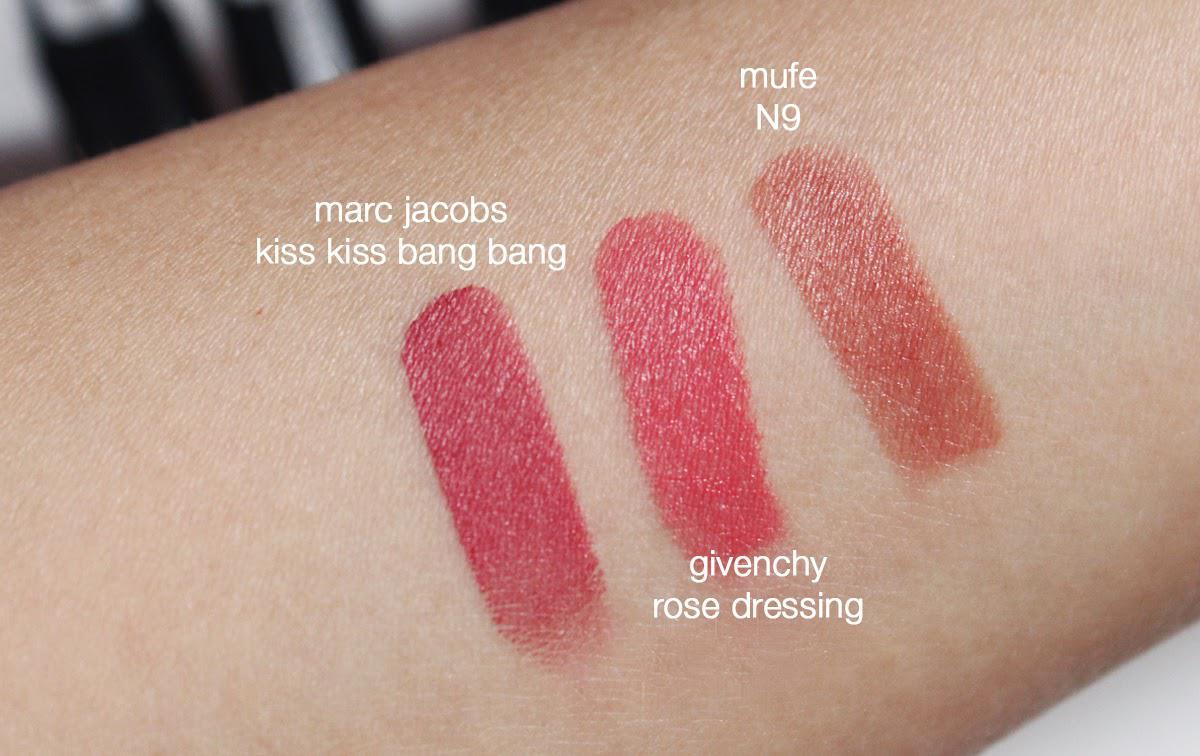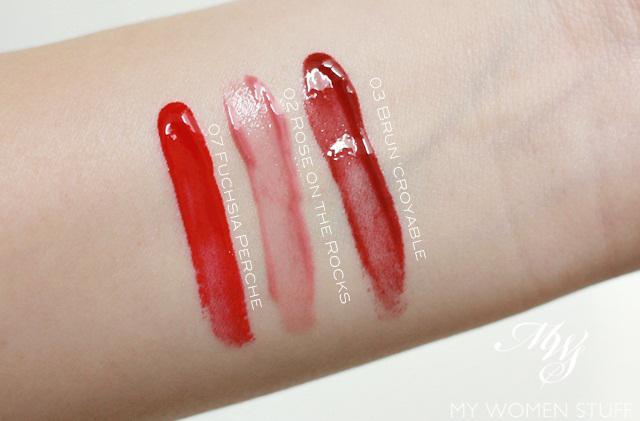The first image is the image on the left, the second image is the image on the right. Assess this claim about the two images: "Each image shows skin with three lipstick sample stripes on it.". Correct or not? Answer yes or no. Yes. The first image is the image on the left, the second image is the image on the right. Considering the images on both sides, is "One of the images does not have three stripes drawn onto skin." valid? Answer yes or no. No. 